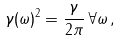<formula> <loc_0><loc_0><loc_500><loc_500>\gamma ( \omega ) ^ { 2 } = \frac { \gamma } { 2 \pi } \, \forall \omega \, ,</formula> 